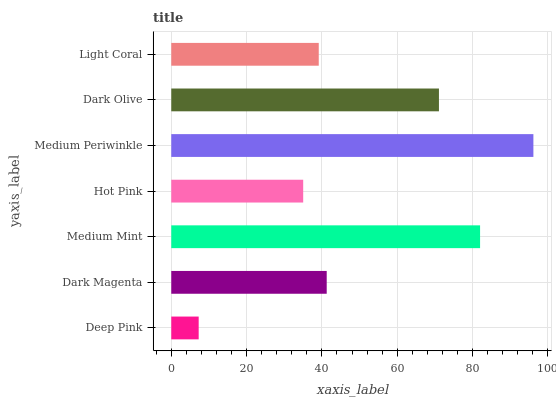Is Deep Pink the minimum?
Answer yes or no. Yes. Is Medium Periwinkle the maximum?
Answer yes or no. Yes. Is Dark Magenta the minimum?
Answer yes or no. No. Is Dark Magenta the maximum?
Answer yes or no. No. Is Dark Magenta greater than Deep Pink?
Answer yes or no. Yes. Is Deep Pink less than Dark Magenta?
Answer yes or no. Yes. Is Deep Pink greater than Dark Magenta?
Answer yes or no. No. Is Dark Magenta less than Deep Pink?
Answer yes or no. No. Is Dark Magenta the high median?
Answer yes or no. Yes. Is Dark Magenta the low median?
Answer yes or no. Yes. Is Deep Pink the high median?
Answer yes or no. No. Is Medium Periwinkle the low median?
Answer yes or no. No. 